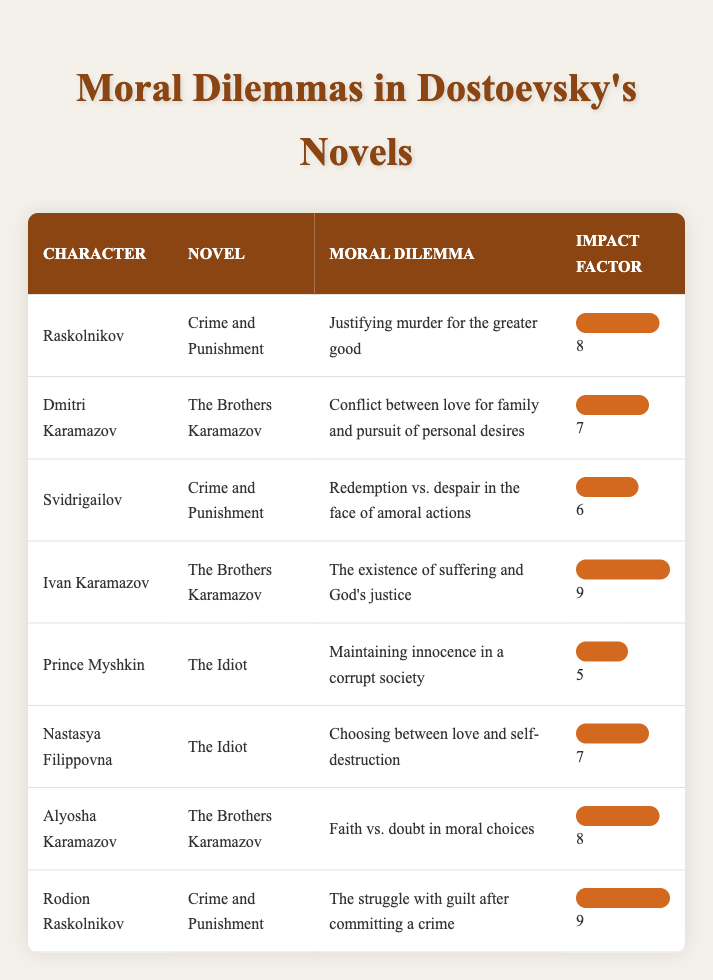What is the moral dilemma faced by Raskolnikov in Crime and Punishment? The table shows that Raskolnikov's moral dilemma is "Justifying murder for the greater good."
Answer: Justifying murder for the greater good Which character has the highest impact factor for their moral dilemma? According to the table, both Ivan Karamazov and Rodion Raskolnikov have the highest impact factor of 9.
Answer: Ivan Karamazov and Rodion Raskolnikov What moral dilemma does Dmitri Karamazov face in The Brothers Karamazov? The table indicates that Dmitri Karamazov's moral dilemma is "Conflict between love for family and pursuit of personal desires."
Answer: Conflict between love for family and pursuit of personal desires What is the average impact factor of the moral dilemmas in The Idiot? There are two impact factors in The Idiot (5 for Prince Myshkin and 7 for Nastasya Filippovna). The sum is 5 + 7 = 12, and the average is 12/2 = 6.
Answer: 6 Is Prince Myshkin's moral dilemma more impactful than that of Svidrigailov in Crime and Punishment? Svidrigailov has an impact factor of 6, whereas Prince Myshkin has an impact factor of 5, making Svidrigailov's dilemma more impactful.
Answer: Yes What moral dilemmas do characters in Crime and Punishment face? The table lists two dilemmas: Raskolnikov faces "Justifying murder for the greater good" and Svidrigailov faces "Redemption vs. despair in the face of amoral actions."
Answer: Justifying murder for the greater good; Redemption vs. despair in the face of amoral actions How many characters in The Brothers Karamazov have an impact factor of 8 or higher? The table shows that both Ivan Karamazov and Alyosha Karamazov (2 characters) have an impact factor of 8 or higher.
Answer: 2 Which character's dilemma involves faith versus doubt? The table specifies that Alyosha Karamazov faces the moral dilemma of "Faith vs. doubt in moral choices."
Answer: Alyosha Karamazov What is the sum of impact factors of characters facing moral dilemmas in The Idiot? The impact factors in The Idiot are 5 and 7. Adding them together gives 5 + 7 = 12.
Answer: 12 